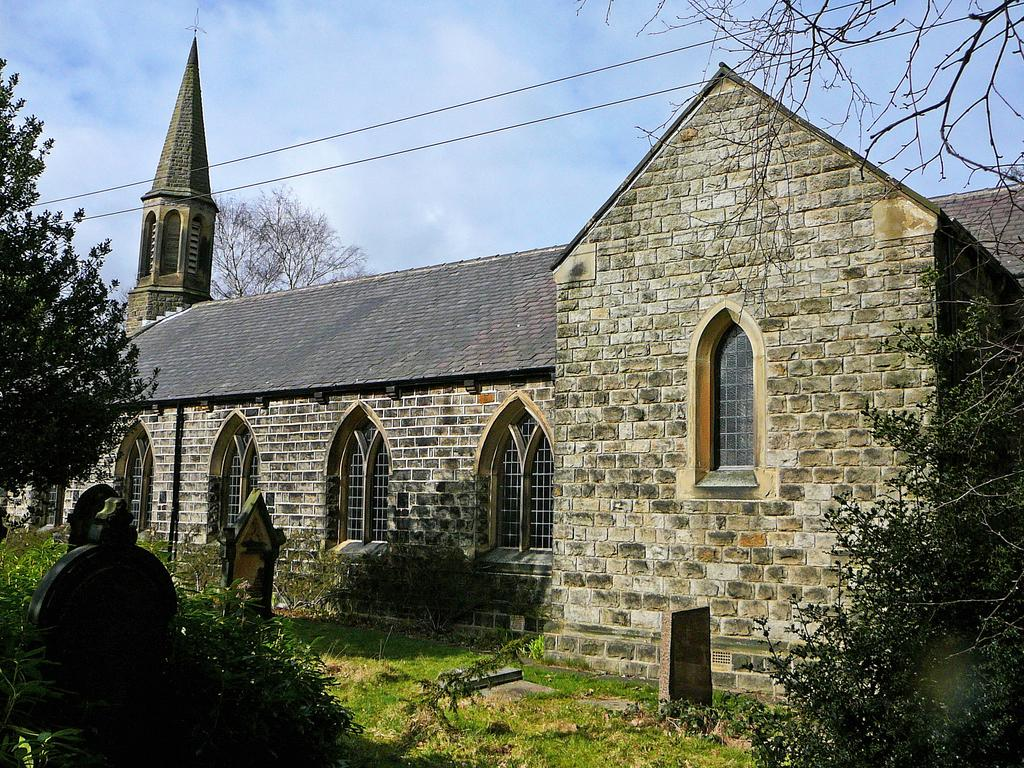What type of vegetation is present in the image? There is grass and trees in the image. What type of structure can be seen in the image? There is a building with windows in the image. What else is visible in the image besides vegetation and the building? There are objects in the image. What can be seen in the background of the image? The sky is visible in the background of the image. What type of lace is draped over the trees in the image? There is no lace present in the image; it features grass, trees, a building, and objects. How are the straws arranged in the image? There are no straws present in the image. 